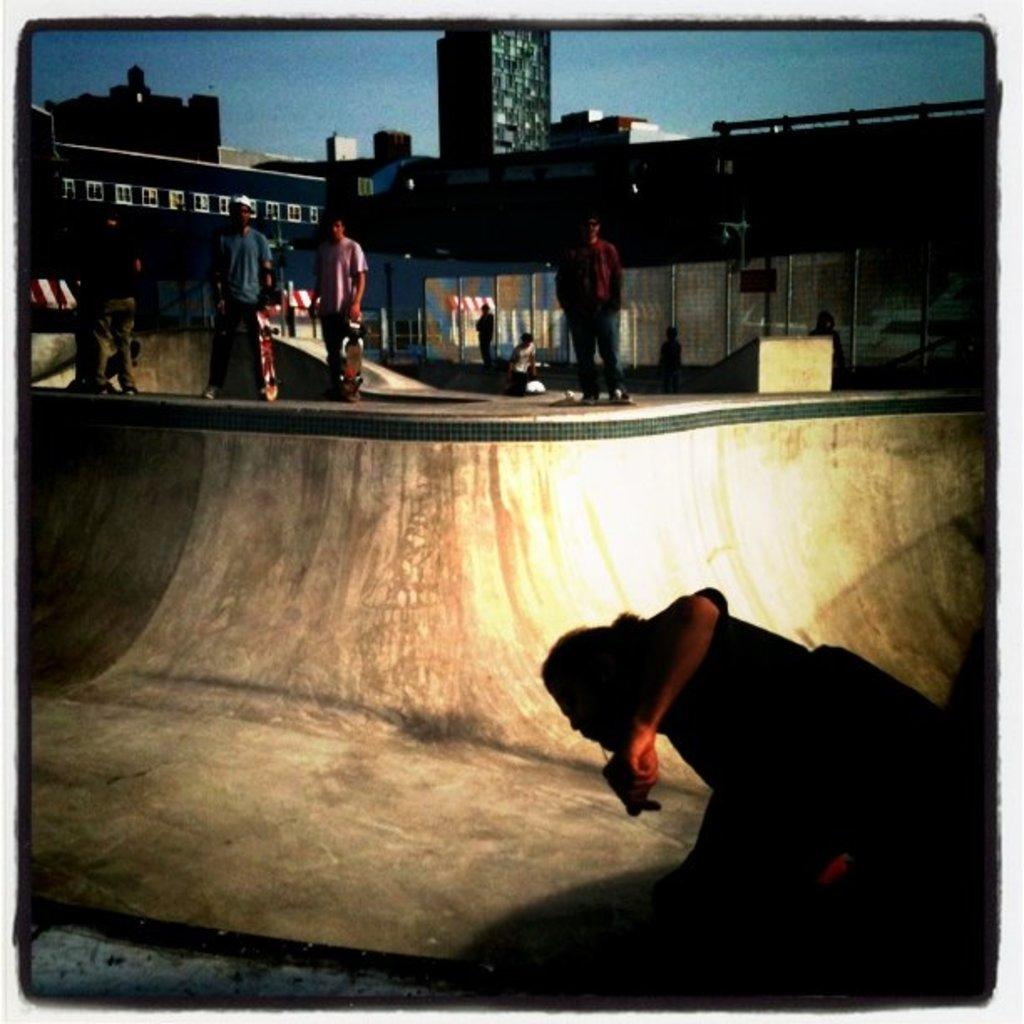What type of structures can be seen in the image? There are buildings in the image. What are the people holding in the image? The people are holding skateboards in the image. What is one person doing with a skateboard in the image? A man is standing on a skateboard in the image. What is another person doing in the image? Another man is skating in the image. What can be seen in the background of the image? The sky is visible in the image. Can you see any caves in the image? There are no caves present in the image. What type of thread is being used by the skateboarders in the image? There is no thread being used by the skateboarders in the image; they are using skateboards. 